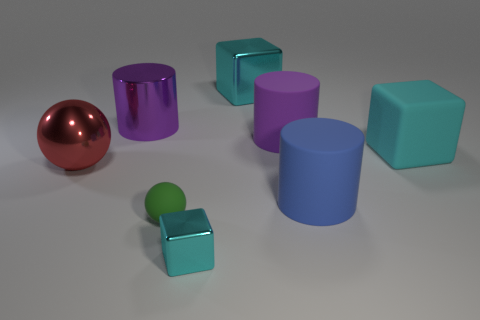There is a cylinder that is in front of the cyan matte block; what material is it?
Provide a succinct answer. Rubber. What is the color of the cube that is made of the same material as the blue cylinder?
Offer a very short reply. Cyan. There is a purple metal thing; does it have the same shape as the cyan thing in front of the green ball?
Keep it short and to the point. No. There is a red metal thing; are there any small blocks behind it?
Ensure brevity in your answer.  No. There is a large thing that is the same color as the large metallic block; what is it made of?
Provide a succinct answer. Rubber. Do the purple rubber thing and the cyan thing that is in front of the rubber sphere have the same size?
Your response must be concise. No. Is there a block of the same color as the small metal thing?
Offer a very short reply. Yes. Is there a big purple shiny object of the same shape as the blue matte thing?
Keep it short and to the point. Yes. There is a cyan thing that is to the left of the blue rubber object and to the right of the tiny block; what shape is it?
Provide a succinct answer. Cube. How many tiny green balls have the same material as the green object?
Ensure brevity in your answer.  0. 